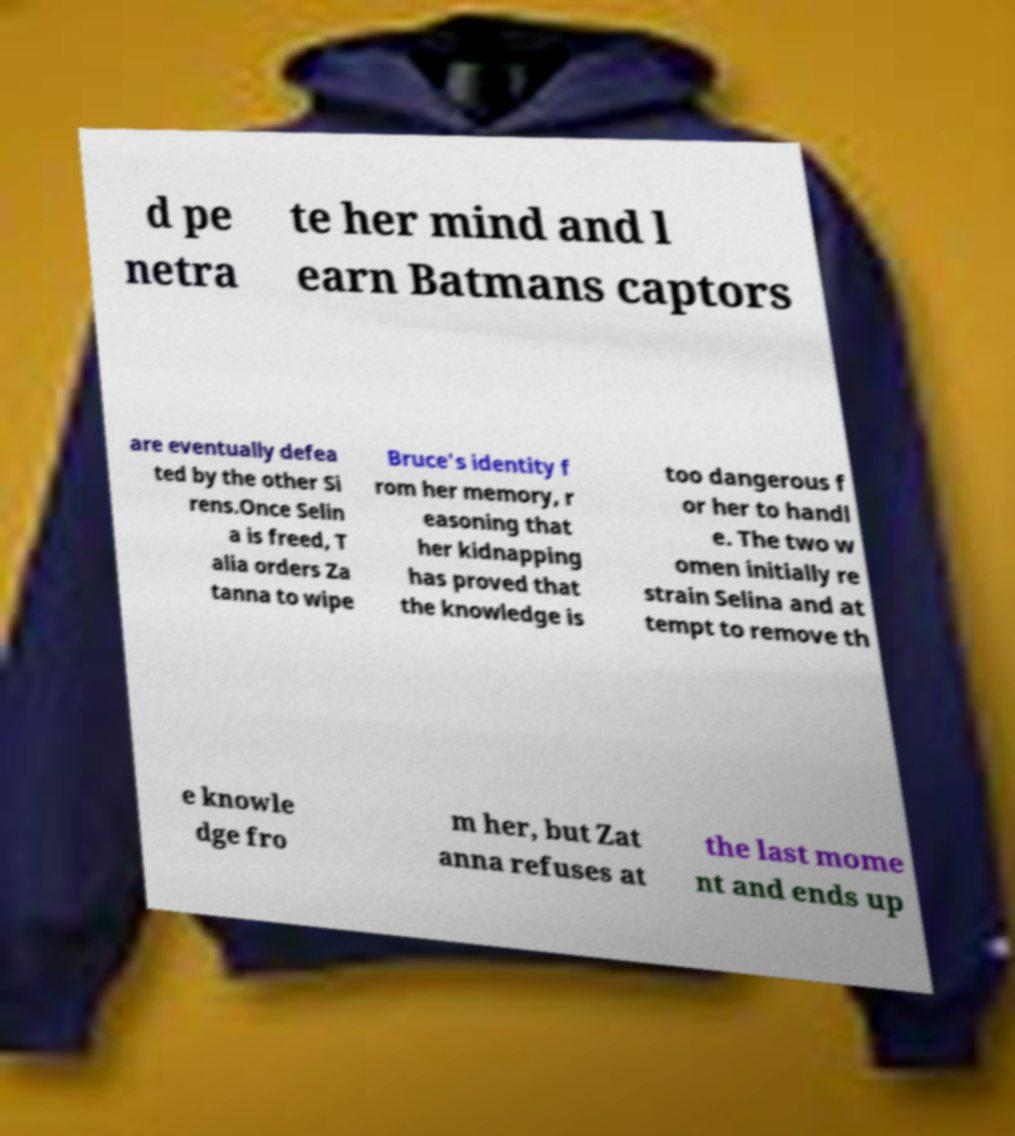Can you read and provide the text displayed in the image?This photo seems to have some interesting text. Can you extract and type it out for me? d pe netra te her mind and l earn Batmans captors are eventually defea ted by the other Si rens.Once Selin a is freed, T alia orders Za tanna to wipe Bruce's identity f rom her memory, r easoning that her kidnapping has proved that the knowledge is too dangerous f or her to handl e. The two w omen initially re strain Selina and at tempt to remove th e knowle dge fro m her, but Zat anna refuses at the last mome nt and ends up 